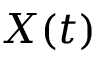<formula> <loc_0><loc_0><loc_500><loc_500>X ( t )</formula> 